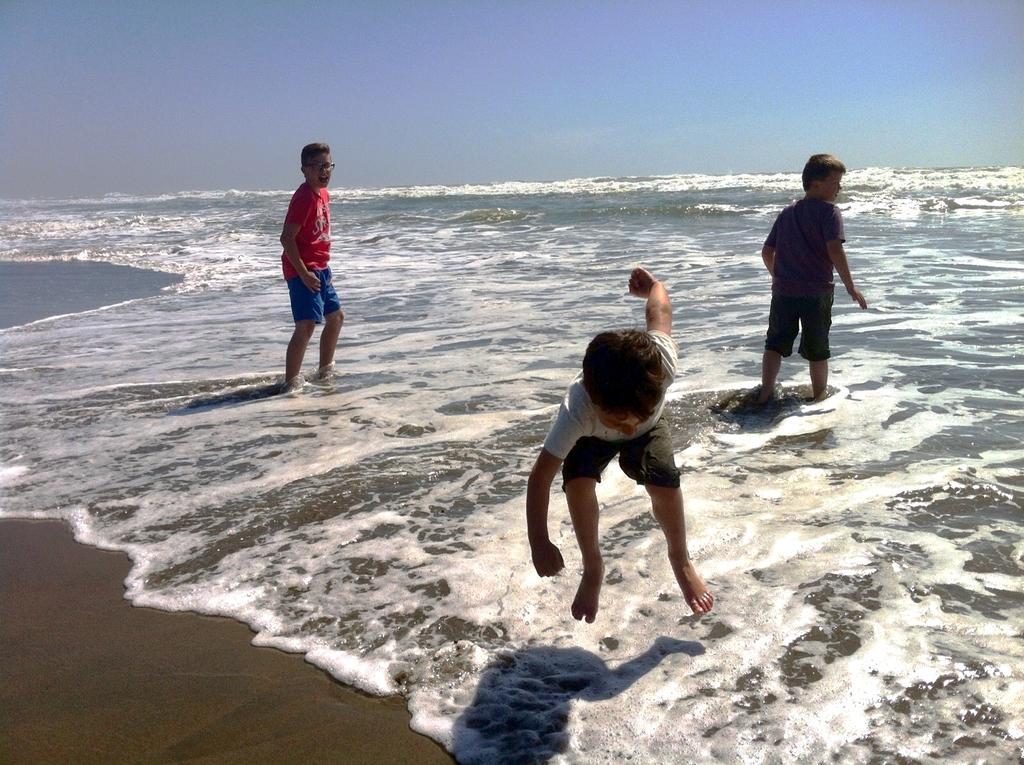In one or two sentences, can you explain what this image depicts? In this image I can see three kids playing on a sea shore one kid in the center of the image is jumping, the other two are standing. At the top of the image I can see the sky.  